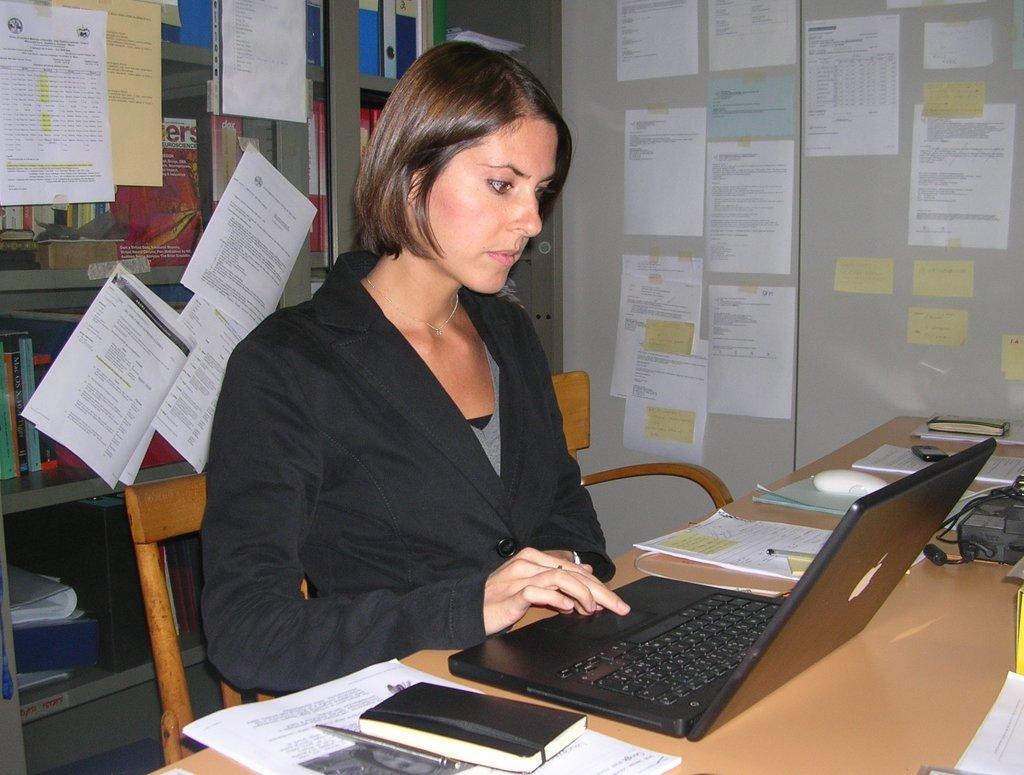What 3 letters are visible in red on the book to the left of the woman's head?
Offer a very short reply. Ers. 